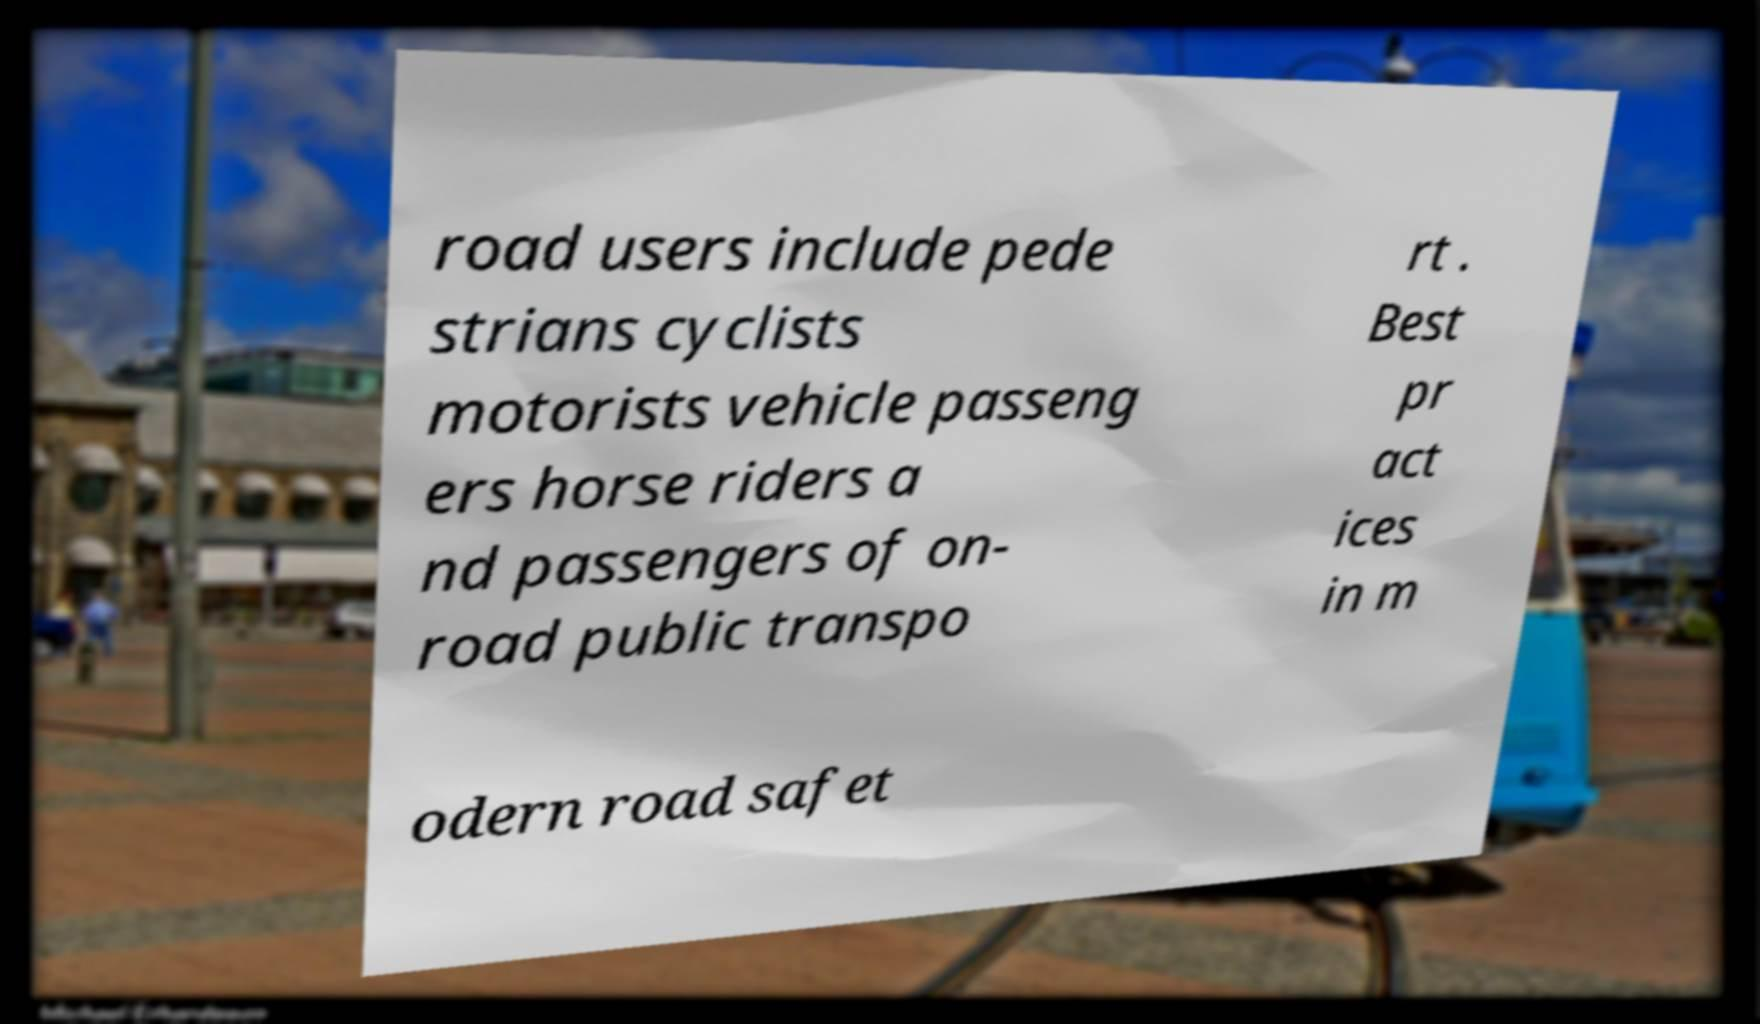Can you read and provide the text displayed in the image?This photo seems to have some interesting text. Can you extract and type it out for me? road users include pede strians cyclists motorists vehicle passeng ers horse riders a nd passengers of on- road public transpo rt . Best pr act ices in m odern road safet 